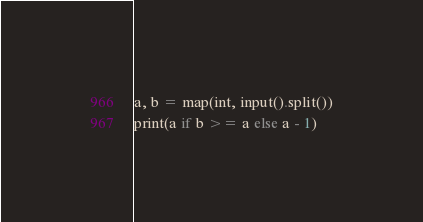<code> <loc_0><loc_0><loc_500><loc_500><_Python_>a, b = map(int, input().split())
print(a if b >= a else a - 1)</code> 